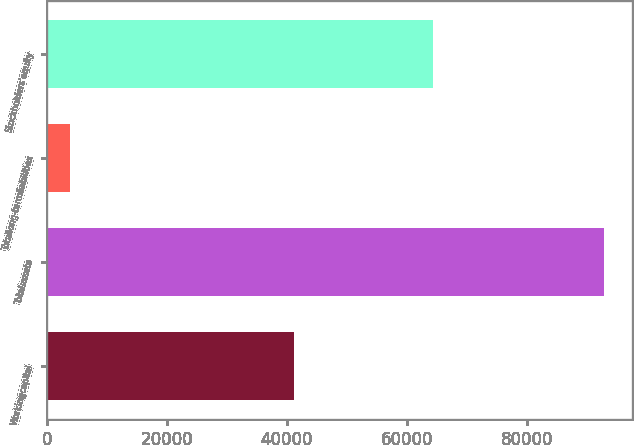Convert chart. <chart><loc_0><loc_0><loc_500><loc_500><bar_chart><fcel>Workingcapital<fcel>Totalassets<fcel>Totallong-termliabilities<fcel>Stockholders'equity<nl><fcel>41160<fcel>92856<fcel>3837<fcel>64347<nl></chart> 